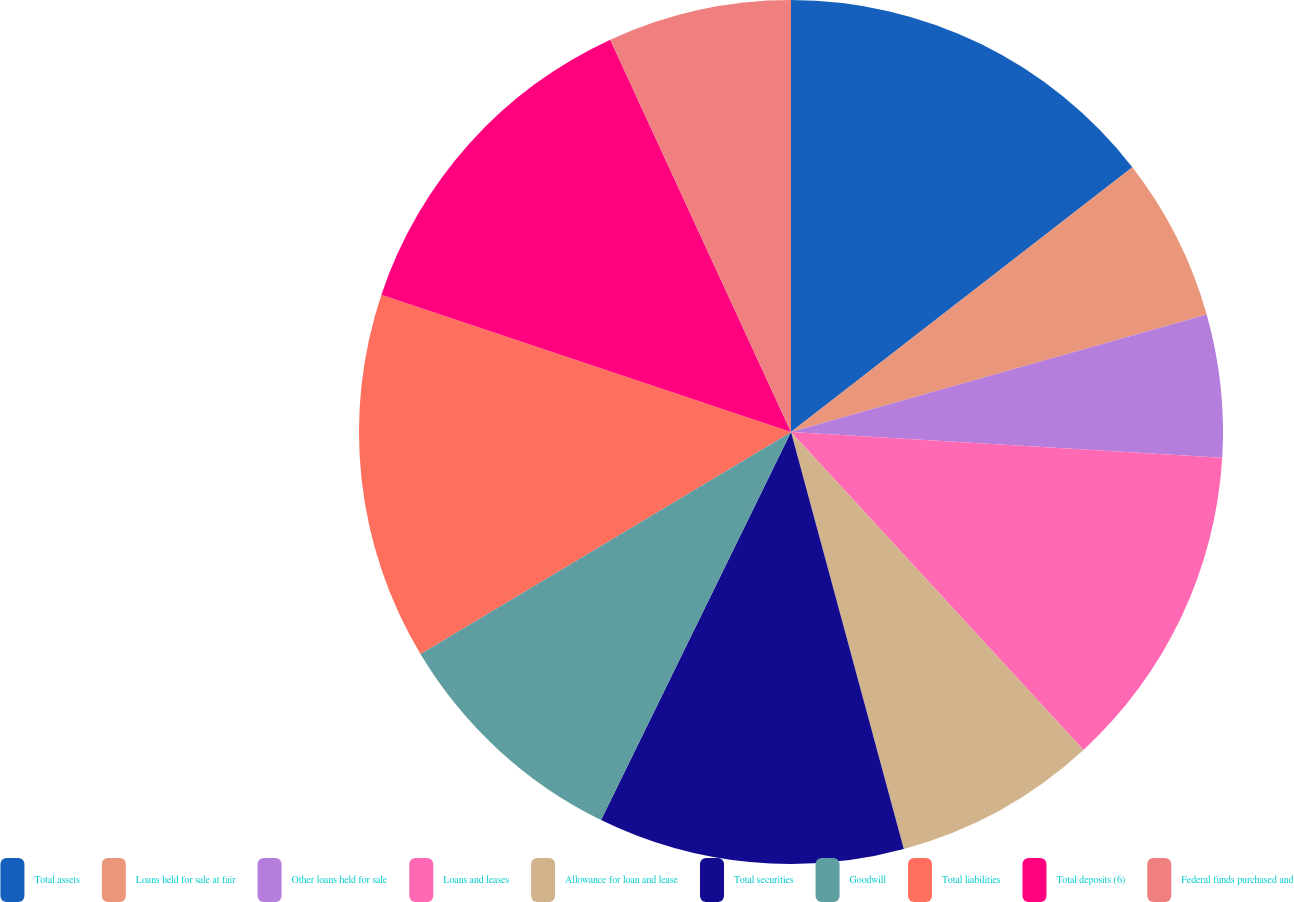Convert chart to OTSL. <chart><loc_0><loc_0><loc_500><loc_500><pie_chart><fcel>Total assets<fcel>Loans held for sale at fair<fcel>Other loans held for sale<fcel>Loans and leases<fcel>Allowance for loan and lease<fcel>Total securities<fcel>Goodwill<fcel>Total liabilities<fcel>Total deposits (6)<fcel>Federal funds purchased and<nl><fcel>14.5%<fcel>6.11%<fcel>5.34%<fcel>12.21%<fcel>7.63%<fcel>11.45%<fcel>9.16%<fcel>13.74%<fcel>12.98%<fcel>6.87%<nl></chart> 